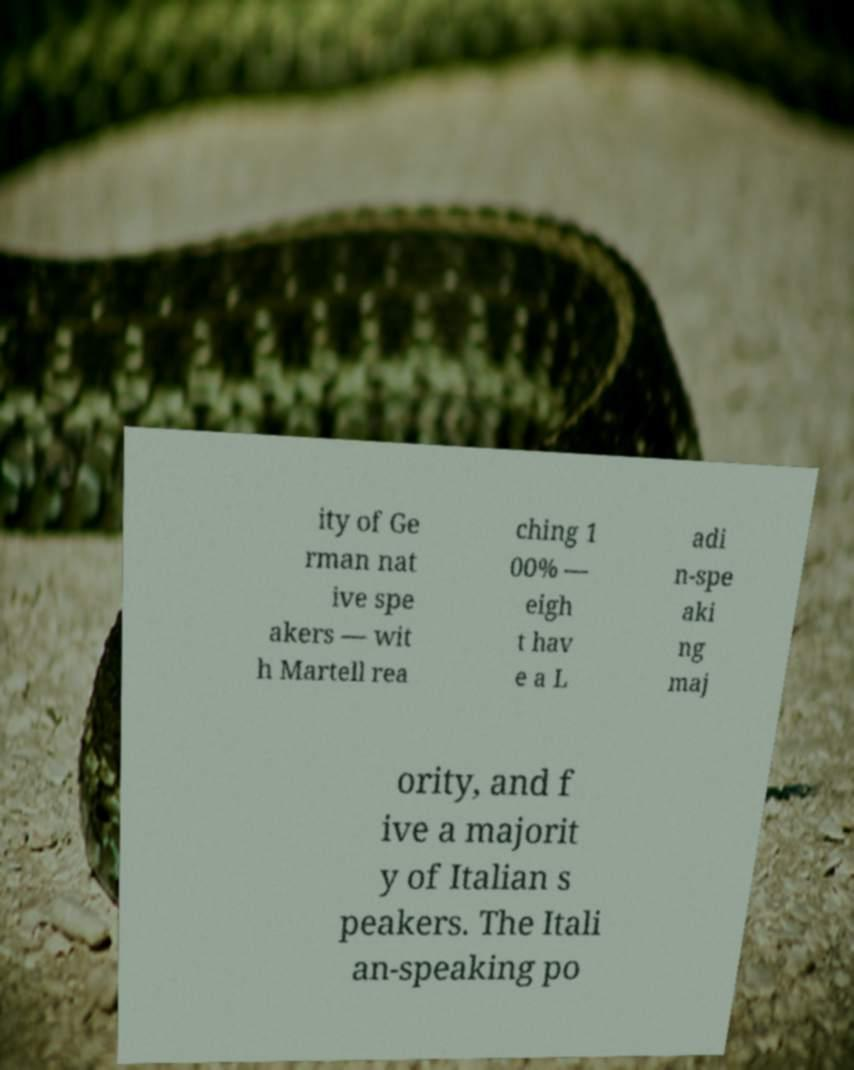Please read and relay the text visible in this image. What does it say? ity of Ge rman nat ive spe akers — wit h Martell rea ching 1 00% — eigh t hav e a L adi n-spe aki ng maj ority, and f ive a majorit y of Italian s peakers. The Itali an-speaking po 